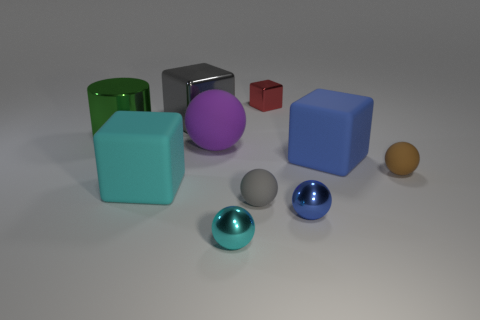What color is the large metal object to the right of the big green cylinder?
Offer a very short reply. Gray. Is the size of the metallic thing that is to the left of the large gray cube the same as the gray thing that is behind the large purple object?
Make the answer very short. Yes. What number of things are either tiny balls or green matte cubes?
Your response must be concise. 4. What is the material of the gray object that is in front of the matte thing that is behind the big blue rubber cube?
Your answer should be compact. Rubber. What number of big green metallic objects have the same shape as the cyan metallic thing?
Ensure brevity in your answer.  0. Are there any other metallic cubes that have the same color as the tiny metal block?
Keep it short and to the point. No. What number of things are either big matte blocks on the left side of the big blue block or metal things that are behind the large shiny cylinder?
Your response must be concise. 3. There is a shiny block left of the large purple thing; are there any large blue cubes to the left of it?
Keep it short and to the point. No. There is a blue thing that is the same size as the cyan cube; what shape is it?
Offer a very short reply. Cube. What number of things are either small metallic things that are in front of the big sphere or small cubes?
Provide a short and direct response. 3. 